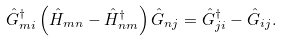<formula> <loc_0><loc_0><loc_500><loc_500>\hat { G } _ { m i } ^ { \dagger } \left ( \hat { H } _ { m n } - \hat { H } _ { n m } ^ { \dagger } \right ) \hat { G } _ { n j } = \hat { G } _ { j i } ^ { \dagger } - \hat { G } _ { i j } .</formula> 